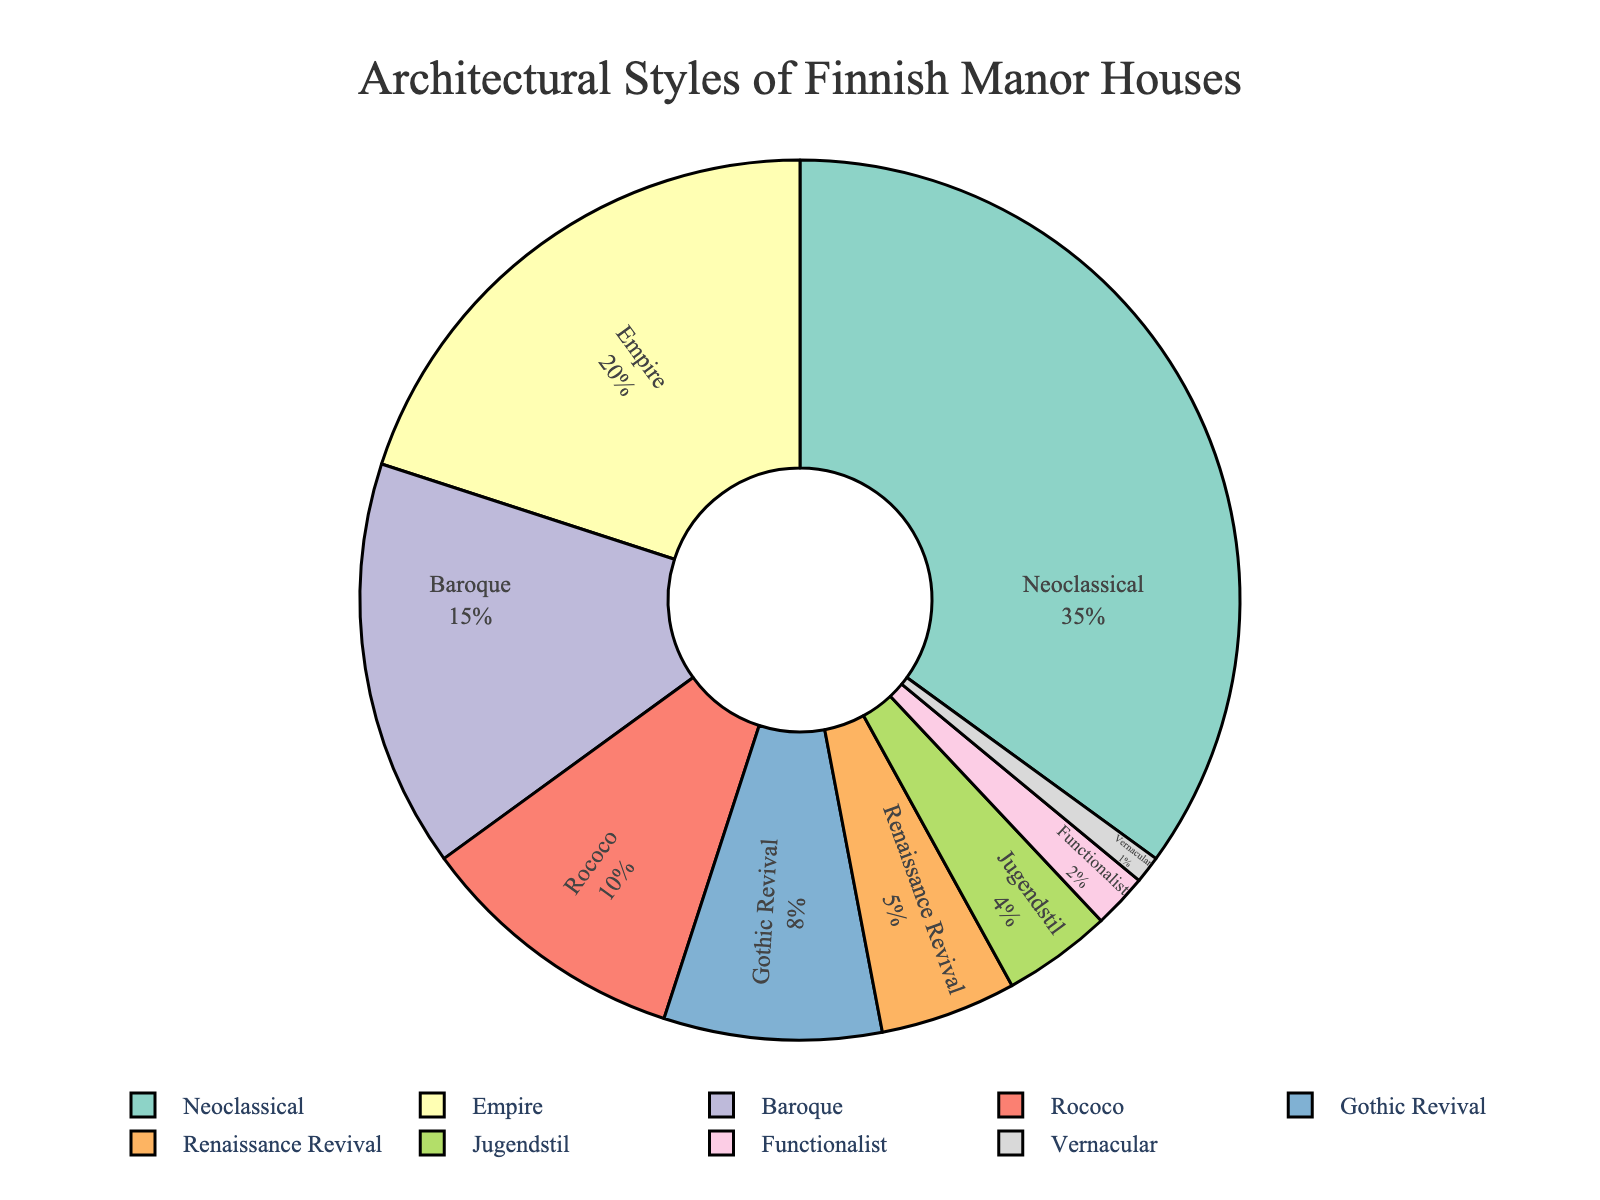What proportion of manor houses follows Neoclassical architectural style? Neoclassical forms the largest single segment of the pie chart. The corresponding label shows its percentage.
Answer: 35% Which architectural style occupies a larger proportion: Gothic Revival or Renaissance Revival? By looking at the pie chart, we can see that the Gothic Revival segment is visually larger than the Renaissance Revival segment. The labels confirm this.
Answer: Gothic Revival What is the combined proportion of Empire and Baroque styles? The pie chart label shows Empire at 20% and Baroque at 15%. Adding these two gives 35%.
Answer: 35% Which styles are represented by more than 5% of the manor houses? Identifying the segments with labels above 5% - Neoclassical (35%), Empire (20%), Baroque (15%), Rococo (10%), Gothic Revival (8%).
Answer: Neoclassical, Empire, Baroque, Rococo, Gothic Revival Which style has the smallest proportion, and what is it? By checking the smallest segment in the pie chart, the Vernacular style is the smallest. The label shows 1%.
Answer: Vernacular, 1% What is the difference in proportion between Rococo and Jugendstil styles? Rococo holds 10% while Jugendstil holds 4%. Subtracting gives 6%.
Answer: 6% Is the proportion of Functionalist style less than half the proportion of Rococo style? Functionalist is at 2%, and Rococo is at 10%. Half of Rococo is 5%. Since 2% is less than 5%, the answer is yes.
Answer: Yes What color represents the Neoclassical style? Based on visual attributes, the segment labeled Neoclassical can be identified by its associated color.
Answer: Light green (approx. #8dd3c7) Which style is represented by a nearly gray segment? The segment with the near-gray color can be identified by cross-referencing its label.
Answer: Vernacular What is the sum of proportions of the three least common styles? Vernacular (1%), Functionalist (2%), and Jugendstil (4%) are the smallest. Summing 1% + 2% + 4% gives 7%.
Answer: 7% 